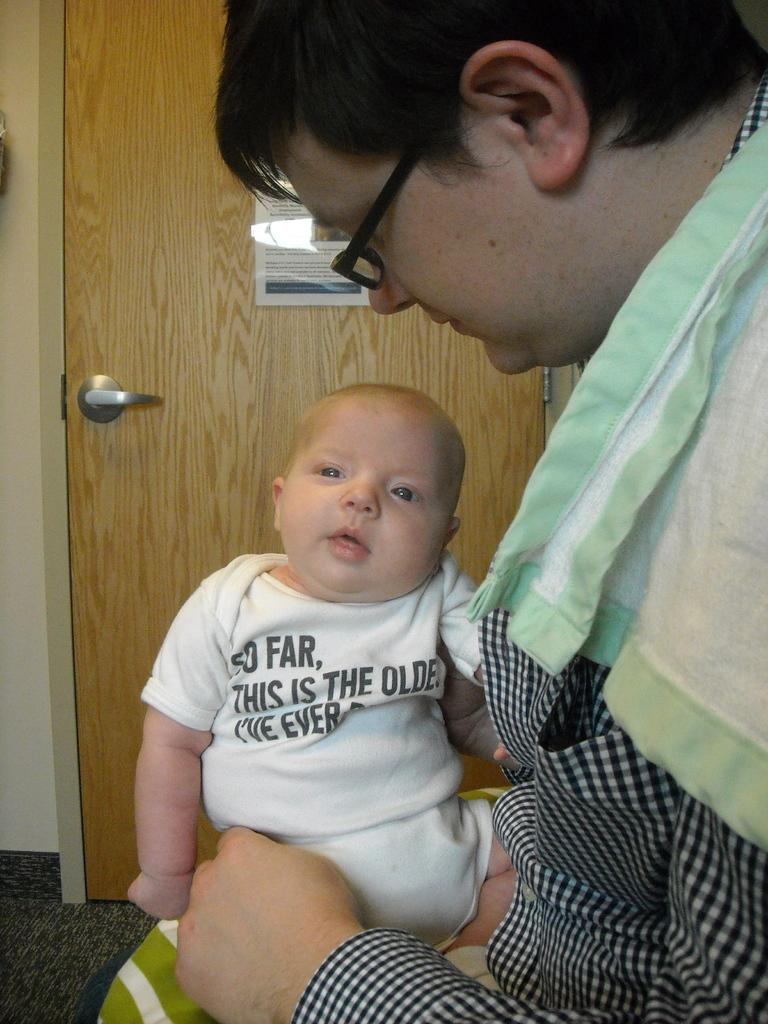Who is present in the image? There is a man and a baby in the image. What are the man and the baby wearing? The man and the baby are both wearing clothes. What accessory is the man wearing? The man is wearing spectacles. What architectural feature can be seen in the image? There is a door in the image. What surface is visible in the image? There is a floor in the image. What additional object is present in the image? There is a poster in the image. What type of record can be seen on the floor in the image? There is no record present in the image; it only features a man, a baby, a door, a floor, and a poster. What kind of sticks are being used by the man in the image? There are no sticks visible in the image; the man is wearing spectacles, not holding any sticks. 